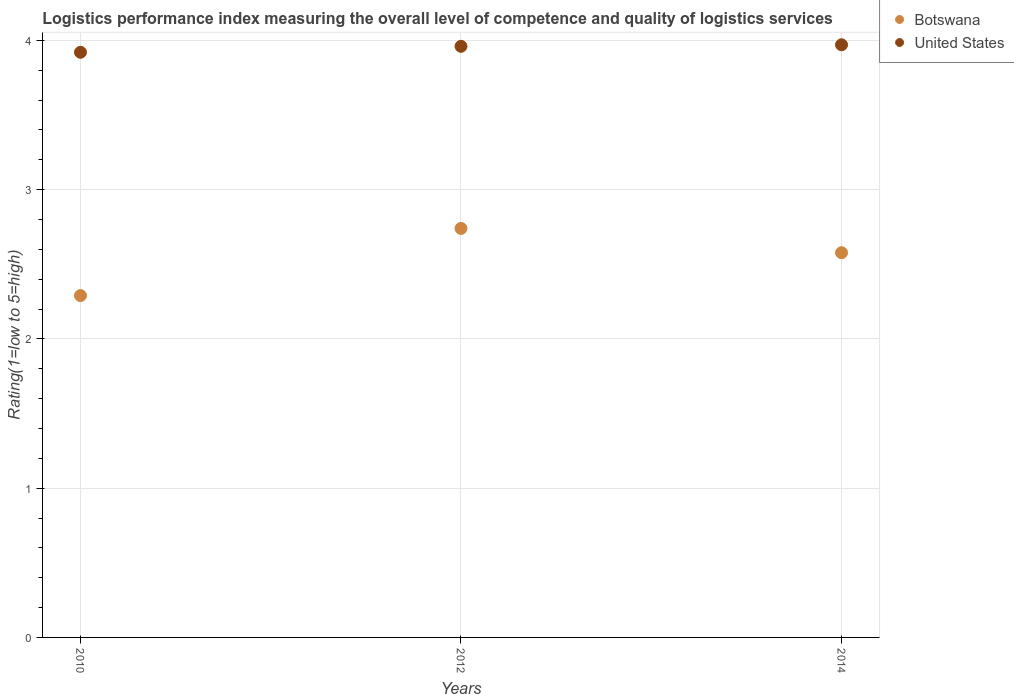How many different coloured dotlines are there?
Offer a terse response. 2. What is the Logistic performance index in United States in 2012?
Keep it short and to the point. 3.96. Across all years, what is the maximum Logistic performance index in Botswana?
Your answer should be very brief. 2.74. Across all years, what is the minimum Logistic performance index in Botswana?
Keep it short and to the point. 2.29. What is the total Logistic performance index in United States in the graph?
Make the answer very short. 11.85. What is the difference between the Logistic performance index in Botswana in 2010 and that in 2014?
Provide a short and direct response. -0.29. What is the difference between the Logistic performance index in United States in 2014 and the Logistic performance index in Botswana in 2012?
Offer a terse response. 1.23. What is the average Logistic performance index in Botswana per year?
Provide a short and direct response. 2.54. In the year 2012, what is the difference between the Logistic performance index in Botswana and Logistic performance index in United States?
Your answer should be very brief. -1.22. What is the ratio of the Logistic performance index in Botswana in 2010 to that in 2012?
Offer a terse response. 0.84. Is the difference between the Logistic performance index in Botswana in 2012 and 2014 greater than the difference between the Logistic performance index in United States in 2012 and 2014?
Ensure brevity in your answer.  Yes. What is the difference between the highest and the second highest Logistic performance index in Botswana?
Keep it short and to the point. 0.16. What is the difference between the highest and the lowest Logistic performance index in Botswana?
Make the answer very short. 0.45. Is the Logistic performance index in Botswana strictly less than the Logistic performance index in United States over the years?
Provide a succinct answer. Yes. What is the difference between two consecutive major ticks on the Y-axis?
Offer a very short reply. 1. Does the graph contain any zero values?
Make the answer very short. No. Does the graph contain grids?
Keep it short and to the point. Yes. How many legend labels are there?
Provide a short and direct response. 2. How are the legend labels stacked?
Give a very brief answer. Vertical. What is the title of the graph?
Provide a succinct answer. Logistics performance index measuring the overall level of competence and quality of logistics services. Does "Monaco" appear as one of the legend labels in the graph?
Keep it short and to the point. No. What is the label or title of the Y-axis?
Give a very brief answer. Rating(1=low to 5=high). What is the Rating(1=low to 5=high) of Botswana in 2010?
Your response must be concise. 2.29. What is the Rating(1=low to 5=high) in United States in 2010?
Ensure brevity in your answer.  3.92. What is the Rating(1=low to 5=high) in Botswana in 2012?
Make the answer very short. 2.74. What is the Rating(1=low to 5=high) of United States in 2012?
Your response must be concise. 3.96. What is the Rating(1=low to 5=high) of Botswana in 2014?
Ensure brevity in your answer.  2.58. What is the Rating(1=low to 5=high) of United States in 2014?
Your answer should be very brief. 3.97. Across all years, what is the maximum Rating(1=low to 5=high) of Botswana?
Provide a short and direct response. 2.74. Across all years, what is the maximum Rating(1=low to 5=high) in United States?
Make the answer very short. 3.97. Across all years, what is the minimum Rating(1=low to 5=high) in Botswana?
Keep it short and to the point. 2.29. Across all years, what is the minimum Rating(1=low to 5=high) in United States?
Your response must be concise. 3.92. What is the total Rating(1=low to 5=high) of Botswana in the graph?
Your answer should be compact. 7.61. What is the total Rating(1=low to 5=high) of United States in the graph?
Your response must be concise. 11.85. What is the difference between the Rating(1=low to 5=high) of Botswana in 2010 and that in 2012?
Give a very brief answer. -0.45. What is the difference between the Rating(1=low to 5=high) in United States in 2010 and that in 2012?
Offer a very short reply. -0.04. What is the difference between the Rating(1=low to 5=high) of Botswana in 2010 and that in 2014?
Your response must be concise. -0.29. What is the difference between the Rating(1=low to 5=high) in United States in 2010 and that in 2014?
Your response must be concise. -0.05. What is the difference between the Rating(1=low to 5=high) of Botswana in 2012 and that in 2014?
Ensure brevity in your answer.  0.16. What is the difference between the Rating(1=low to 5=high) of United States in 2012 and that in 2014?
Provide a succinct answer. -0.01. What is the difference between the Rating(1=low to 5=high) of Botswana in 2010 and the Rating(1=low to 5=high) of United States in 2012?
Give a very brief answer. -1.67. What is the difference between the Rating(1=low to 5=high) of Botswana in 2010 and the Rating(1=low to 5=high) of United States in 2014?
Offer a very short reply. -1.68. What is the difference between the Rating(1=low to 5=high) of Botswana in 2012 and the Rating(1=low to 5=high) of United States in 2014?
Your answer should be compact. -1.23. What is the average Rating(1=low to 5=high) of Botswana per year?
Keep it short and to the point. 2.54. What is the average Rating(1=low to 5=high) in United States per year?
Offer a very short reply. 3.95. In the year 2010, what is the difference between the Rating(1=low to 5=high) of Botswana and Rating(1=low to 5=high) of United States?
Offer a very short reply. -1.63. In the year 2012, what is the difference between the Rating(1=low to 5=high) in Botswana and Rating(1=low to 5=high) in United States?
Provide a succinct answer. -1.22. In the year 2014, what is the difference between the Rating(1=low to 5=high) of Botswana and Rating(1=low to 5=high) of United States?
Your answer should be very brief. -1.39. What is the ratio of the Rating(1=low to 5=high) in Botswana in 2010 to that in 2012?
Offer a terse response. 0.84. What is the ratio of the Rating(1=low to 5=high) of Botswana in 2010 to that in 2014?
Provide a short and direct response. 0.89. What is the ratio of the Rating(1=low to 5=high) of United States in 2010 to that in 2014?
Your answer should be compact. 0.99. What is the ratio of the Rating(1=low to 5=high) of Botswana in 2012 to that in 2014?
Your answer should be compact. 1.06. What is the difference between the highest and the second highest Rating(1=low to 5=high) in Botswana?
Your answer should be very brief. 0.16. What is the difference between the highest and the second highest Rating(1=low to 5=high) of United States?
Your response must be concise. 0.01. What is the difference between the highest and the lowest Rating(1=low to 5=high) in Botswana?
Ensure brevity in your answer.  0.45. What is the difference between the highest and the lowest Rating(1=low to 5=high) in United States?
Make the answer very short. 0.05. 